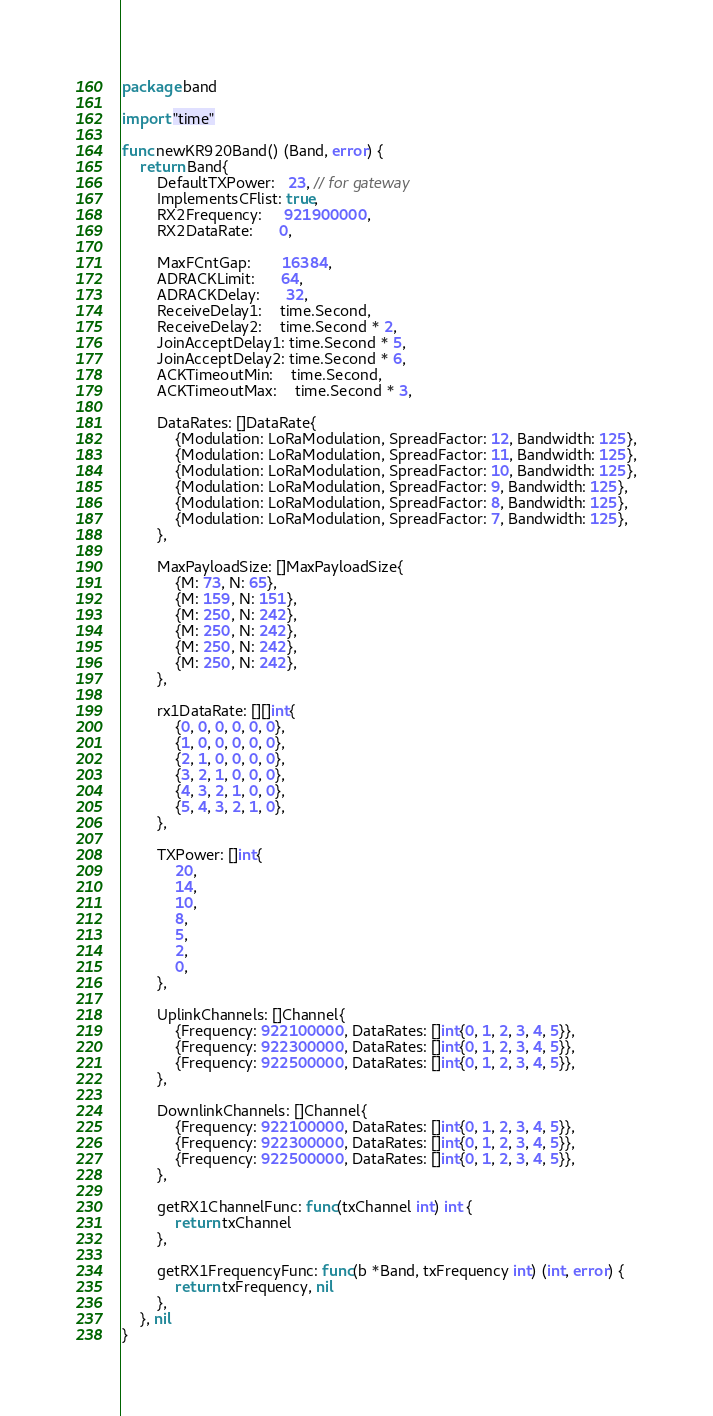<code> <loc_0><loc_0><loc_500><loc_500><_Go_>package band

import "time"

func newKR920Band() (Band, error) {
	return Band{
		DefaultTXPower:   23, // for gateway
		ImplementsCFlist: true,
		RX2Frequency:     921900000,
		RX2DataRate:      0,

		MaxFCntGap:       16384,
		ADRACKLimit:      64,
		ADRACKDelay:      32,
		ReceiveDelay1:    time.Second,
		ReceiveDelay2:    time.Second * 2,
		JoinAcceptDelay1: time.Second * 5,
		JoinAcceptDelay2: time.Second * 6,
		ACKTimeoutMin:    time.Second,
		ACKTimeoutMax:    time.Second * 3,

		DataRates: []DataRate{
			{Modulation: LoRaModulation, SpreadFactor: 12, Bandwidth: 125},
			{Modulation: LoRaModulation, SpreadFactor: 11, Bandwidth: 125},
			{Modulation: LoRaModulation, SpreadFactor: 10, Bandwidth: 125},
			{Modulation: LoRaModulation, SpreadFactor: 9, Bandwidth: 125},
			{Modulation: LoRaModulation, SpreadFactor: 8, Bandwidth: 125},
			{Modulation: LoRaModulation, SpreadFactor: 7, Bandwidth: 125},
		},

		MaxPayloadSize: []MaxPayloadSize{
			{M: 73, N: 65},
			{M: 159, N: 151},
			{M: 250, N: 242},
			{M: 250, N: 242},
			{M: 250, N: 242},
			{M: 250, N: 242},
		},

		rx1DataRate: [][]int{
			{0, 0, 0, 0, 0, 0},
			{1, 0, 0, 0, 0, 0},
			{2, 1, 0, 0, 0, 0},
			{3, 2, 1, 0, 0, 0},
			{4, 3, 2, 1, 0, 0},
			{5, 4, 3, 2, 1, 0},
		},

		TXPower: []int{
			20,
			14,
			10,
			8,
			5,
			2,
			0,
		},

		UplinkChannels: []Channel{
			{Frequency: 922100000, DataRates: []int{0, 1, 2, 3, 4, 5}},
			{Frequency: 922300000, DataRates: []int{0, 1, 2, 3, 4, 5}},
			{Frequency: 922500000, DataRates: []int{0, 1, 2, 3, 4, 5}},
		},

		DownlinkChannels: []Channel{
			{Frequency: 922100000, DataRates: []int{0, 1, 2, 3, 4, 5}},
			{Frequency: 922300000, DataRates: []int{0, 1, 2, 3, 4, 5}},
			{Frequency: 922500000, DataRates: []int{0, 1, 2, 3, 4, 5}},
		},

		getRX1ChannelFunc: func(txChannel int) int {
			return txChannel
		},

		getRX1FrequencyFunc: func(b *Band, txFrequency int) (int, error) {
			return txFrequency, nil
		},
	}, nil
}
</code> 